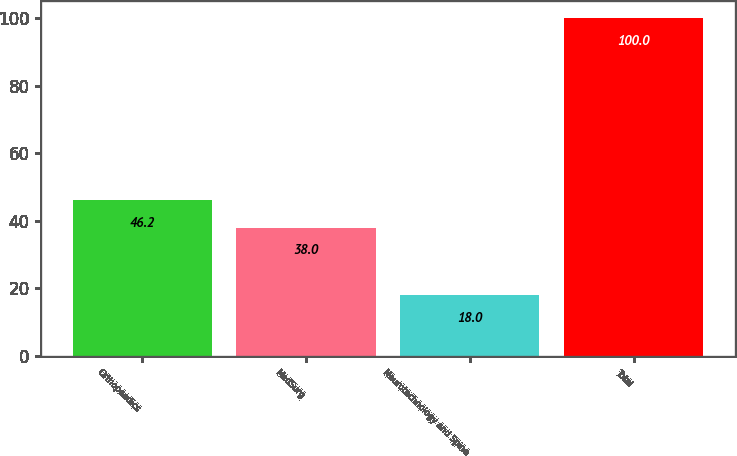Convert chart. <chart><loc_0><loc_0><loc_500><loc_500><bar_chart><fcel>Orthopaedics<fcel>MedSurg<fcel>Neurotechnology and Spine<fcel>Total<nl><fcel>46.2<fcel>38<fcel>18<fcel>100<nl></chart> 